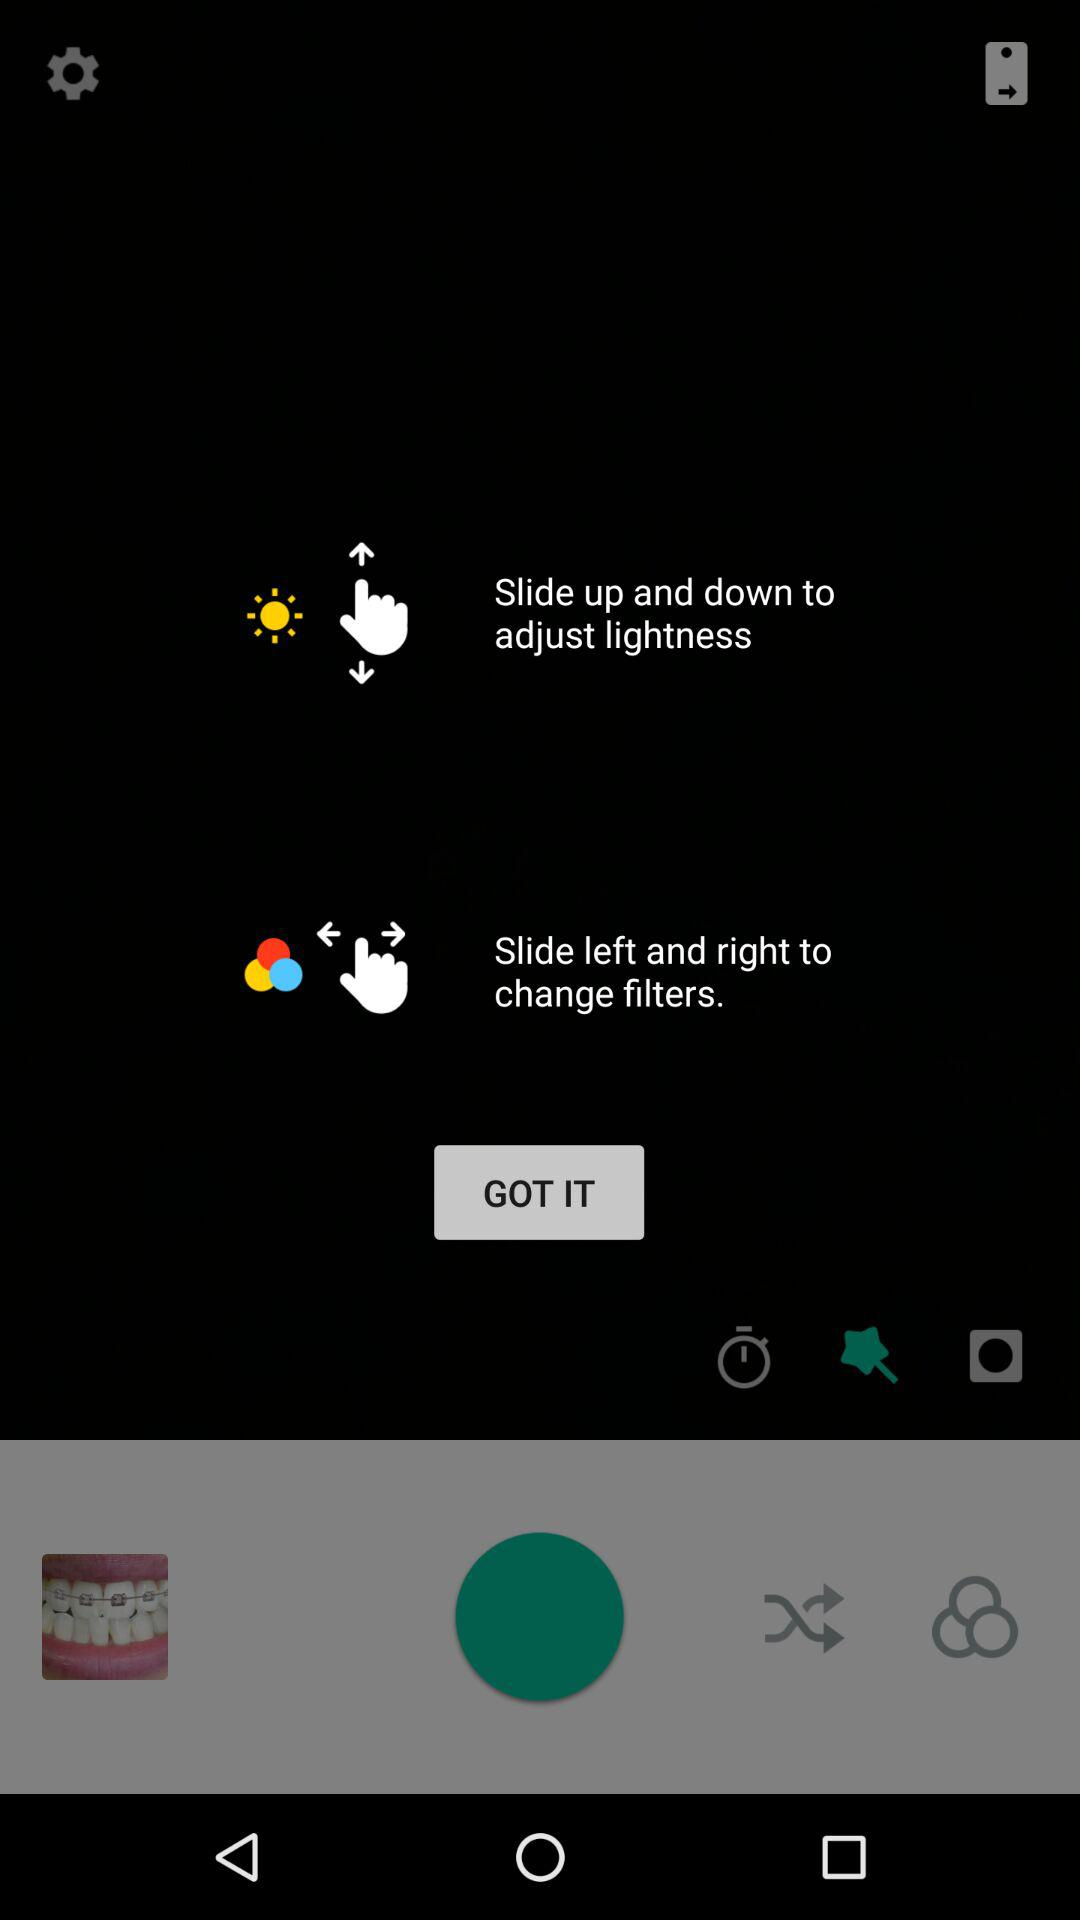How many levels of lightness are there?
When the provided information is insufficient, respond with <no answer>. <no answer> 